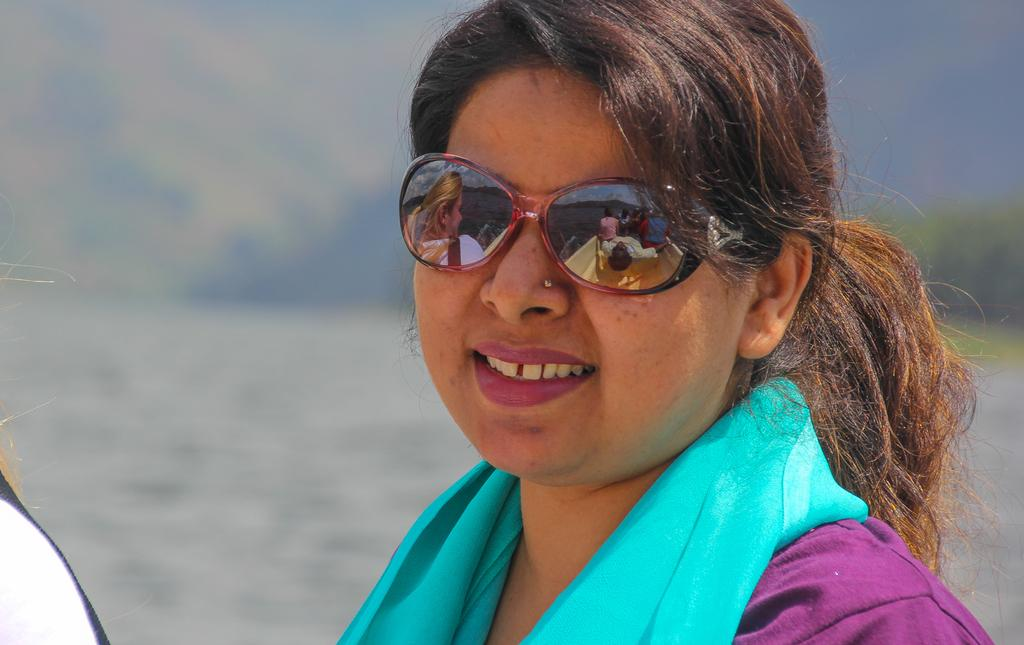Who is present in the image? There is a woman in the image. What is the woman's expression? The woman is smiling. What can be seen in the background of the image? There is water visible in the image. What month is written on the note in the image? There is no note present in the image, so it is not possible to determine the month. 